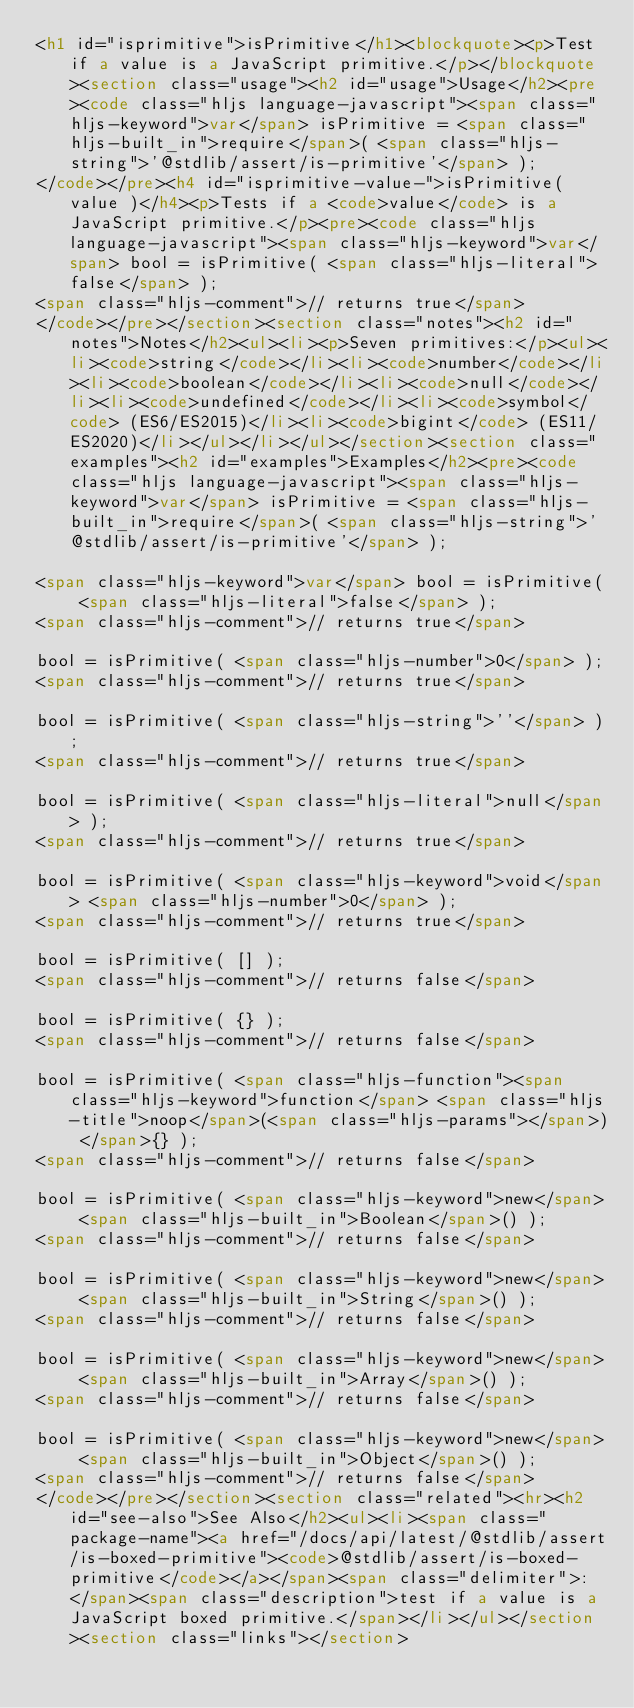Convert code to text. <code><loc_0><loc_0><loc_500><loc_500><_HTML_><h1 id="isprimitive">isPrimitive</h1><blockquote><p>Test if a value is a JavaScript primitive.</p></blockquote><section class="usage"><h2 id="usage">Usage</h2><pre><code class="hljs language-javascript"><span class="hljs-keyword">var</span> isPrimitive = <span class="hljs-built_in">require</span>( <span class="hljs-string">'@stdlib/assert/is-primitive'</span> );
</code></pre><h4 id="isprimitive-value-">isPrimitive( value )</h4><p>Tests if a <code>value</code> is a JavaScript primitive.</p><pre><code class="hljs language-javascript"><span class="hljs-keyword">var</span> bool = isPrimitive( <span class="hljs-literal">false</span> );
<span class="hljs-comment">// returns true</span>
</code></pre></section><section class="notes"><h2 id="notes">Notes</h2><ul><li><p>Seven primitives:</p><ul><li><code>string</code></li><li><code>number</code></li><li><code>boolean</code></li><li><code>null</code></li><li><code>undefined</code></li><li><code>symbol</code> (ES6/ES2015)</li><li><code>bigint</code> (ES11/ES2020)</li></ul></li></ul></section><section class="examples"><h2 id="examples">Examples</h2><pre><code class="hljs language-javascript"><span class="hljs-keyword">var</span> isPrimitive = <span class="hljs-built_in">require</span>( <span class="hljs-string">'@stdlib/assert/is-primitive'</span> );

<span class="hljs-keyword">var</span> bool = isPrimitive( <span class="hljs-literal">false</span> );
<span class="hljs-comment">// returns true</span>

bool = isPrimitive( <span class="hljs-number">0</span> );
<span class="hljs-comment">// returns true</span>

bool = isPrimitive( <span class="hljs-string">''</span> );
<span class="hljs-comment">// returns true</span>

bool = isPrimitive( <span class="hljs-literal">null</span> );
<span class="hljs-comment">// returns true</span>

bool = isPrimitive( <span class="hljs-keyword">void</span> <span class="hljs-number">0</span> );
<span class="hljs-comment">// returns true</span>

bool = isPrimitive( [] );
<span class="hljs-comment">// returns false</span>

bool = isPrimitive( {} );
<span class="hljs-comment">// returns false</span>

bool = isPrimitive( <span class="hljs-function"><span class="hljs-keyword">function</span> <span class="hljs-title">noop</span>(<span class="hljs-params"></span>) </span>{} );
<span class="hljs-comment">// returns false</span>

bool = isPrimitive( <span class="hljs-keyword">new</span> <span class="hljs-built_in">Boolean</span>() );
<span class="hljs-comment">// returns false</span>

bool = isPrimitive( <span class="hljs-keyword">new</span> <span class="hljs-built_in">String</span>() );
<span class="hljs-comment">// returns false</span>

bool = isPrimitive( <span class="hljs-keyword">new</span> <span class="hljs-built_in">Array</span>() );
<span class="hljs-comment">// returns false</span>

bool = isPrimitive( <span class="hljs-keyword">new</span> <span class="hljs-built_in">Object</span>() );
<span class="hljs-comment">// returns false</span>
</code></pre></section><section class="related"><hr><h2 id="see-also">See Also</h2><ul><li><span class="package-name"><a href="/docs/api/latest/@stdlib/assert/is-boxed-primitive"><code>@stdlib/assert/is-boxed-primitive</code></a></span><span class="delimiter">: </span><span class="description">test if a value is a JavaScript boxed primitive.</span></li></ul></section><section class="links"></section></code> 